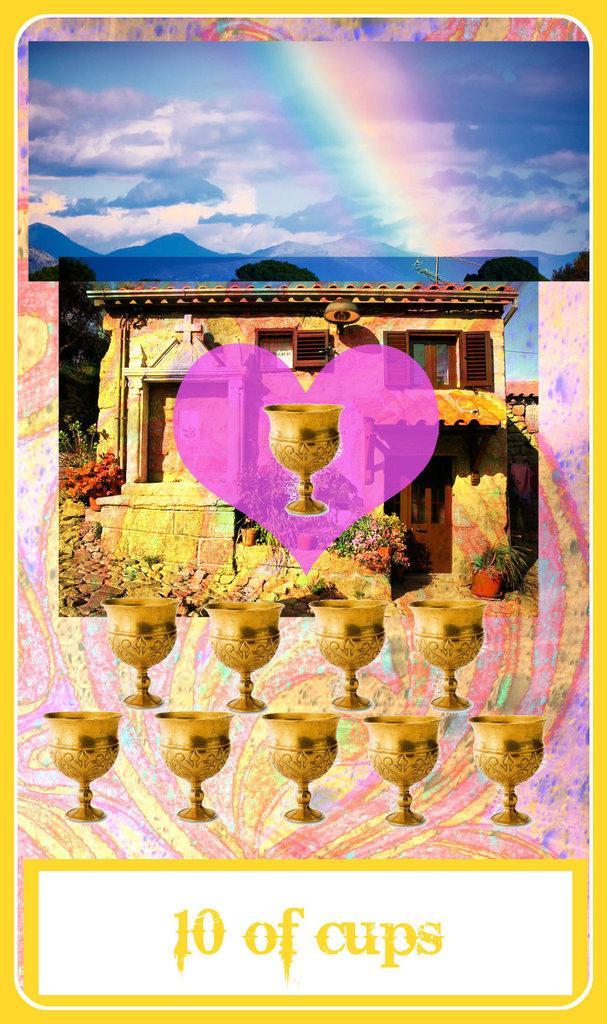Could you give a brief overview of what you see in this image? In this image there is an animated image in which there are cups which are golden in colour and there is a building and there are flowers and the sky is cloudy. 